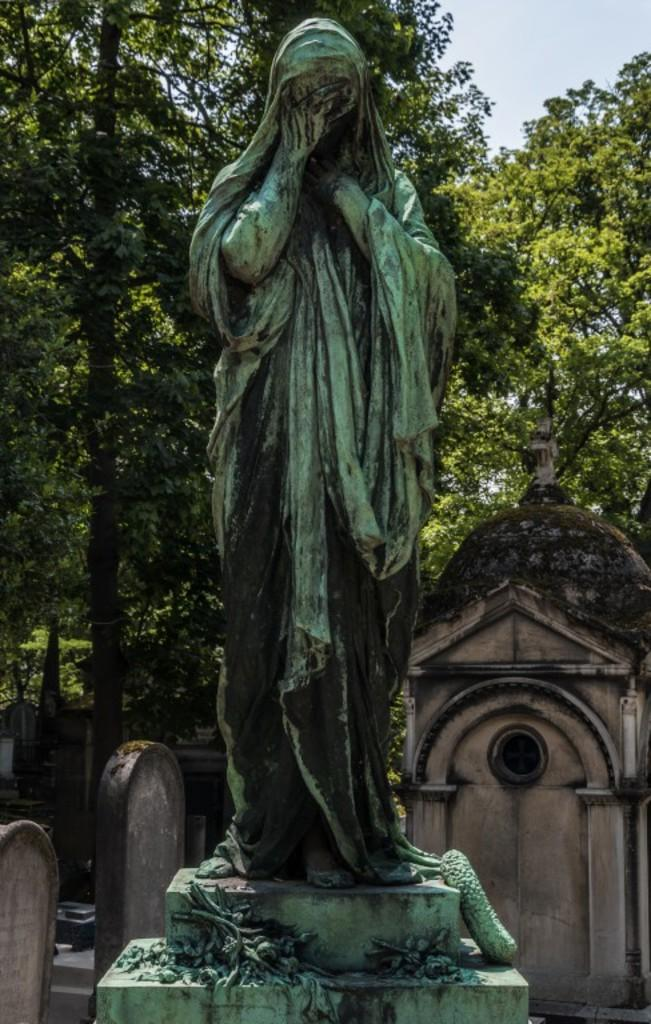What is the main subject in the center of the image? There is a statue in the center of the image. What is the statue standing on? The statue is on a solid structure. What can be seen in the background of the image? There is sky, trees, and headstones visible in the background of the image. Can you see any fog in the image? There is no fog visible in the image. Are there any people in the image exchanging a kiss? There are no people visible in the image, let alone exchanging a kiss. 